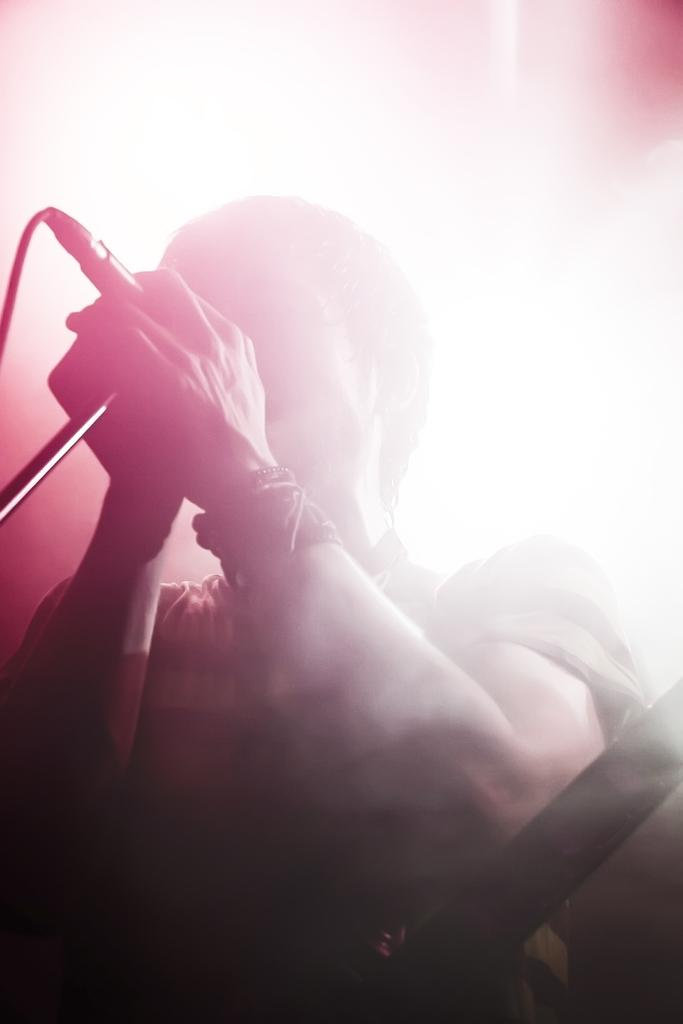What is the person in the image doing? The person is holding a microphone and singing. What object is the person holding while singing? The person is holding a microphone. What can be seen in the background of the image? There is bright light in the background of the image. What type of hate can be seen on the person's face in the image? There is no hate visible on the person's face in the image; they are singing. What is the person using to collect popcorn in the image? There is no popcorn or bucket present in the image. 